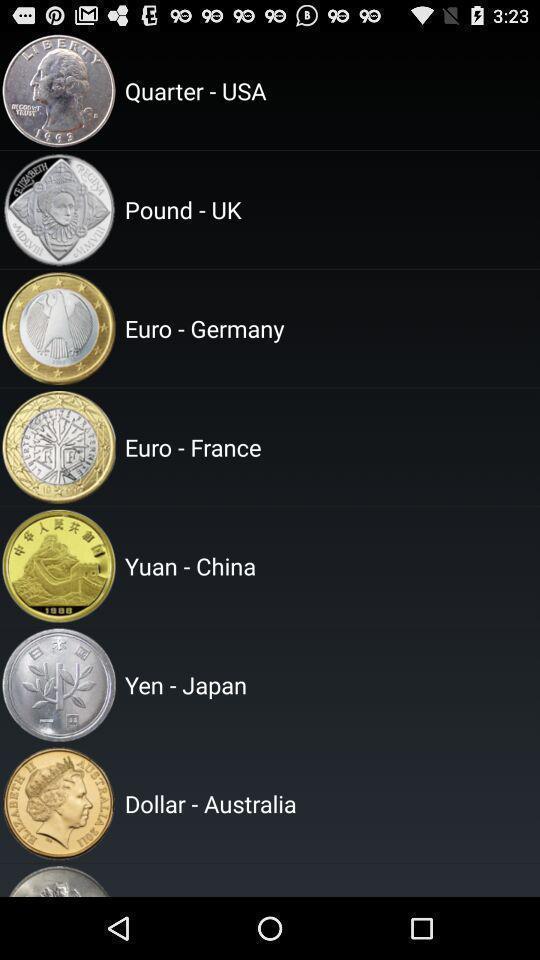Give me a summary of this screen capture. Page showing currency with country. 